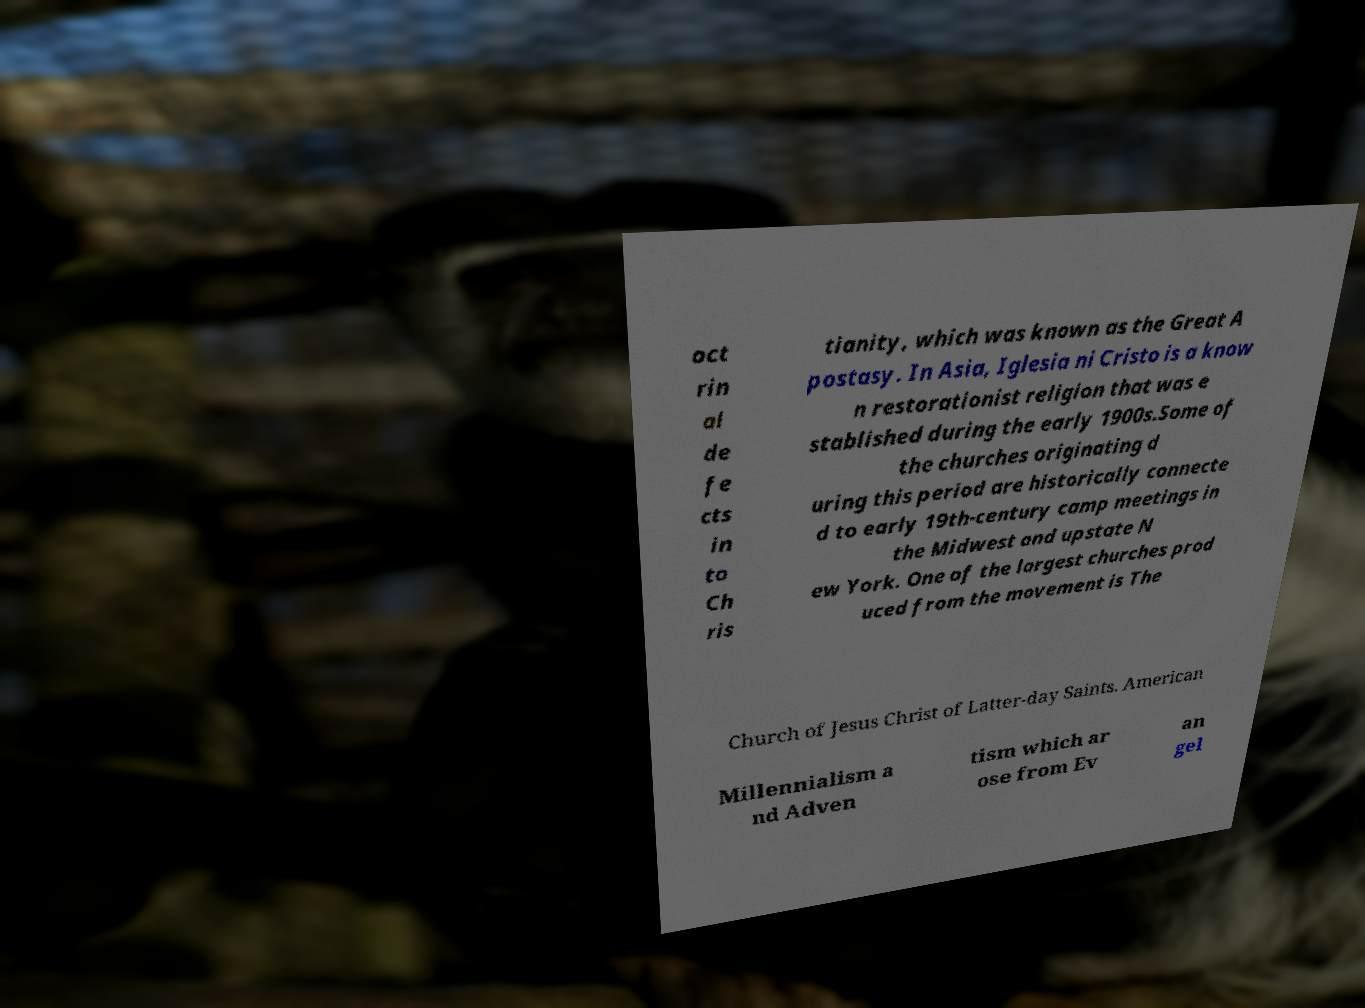I need the written content from this picture converted into text. Can you do that? oct rin al de fe cts in to Ch ris tianity, which was known as the Great A postasy. In Asia, Iglesia ni Cristo is a know n restorationist religion that was e stablished during the early 1900s.Some of the churches originating d uring this period are historically connecte d to early 19th-century camp meetings in the Midwest and upstate N ew York. One of the largest churches prod uced from the movement is The Church of Jesus Christ of Latter-day Saints. American Millennialism a nd Adven tism which ar ose from Ev an gel 